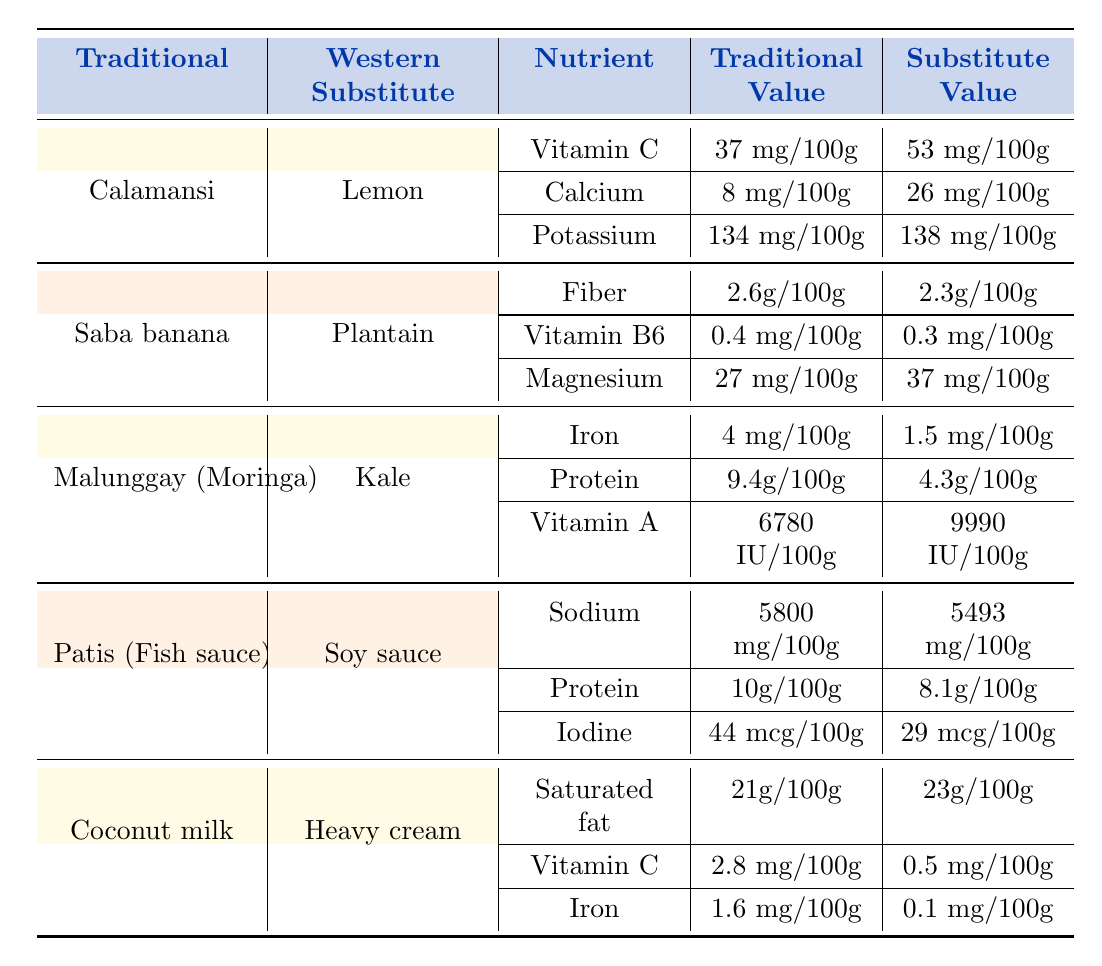What is the Vitamin C content of Calamansi and Lemon? The table shows that Calamansi contains 37 mg of Vitamin C per 100g, while Lemon has 53 mg per 100g.
Answer: Calamansi: 37 mg, Lemon: 53 mg Is the Iron content higher in Malunggay or Kale? According to the table, Malunggay contains 4 mg of Iron per 100g, while Kale has only 1.5 mg per 100g. Therefore, Malunggay has a higher Iron content.
Answer: Yes, Malunggay has higher Iron content What is the difference in Protein content between Patis and Soy sauce? The table indicates that Patis has 10 g of Protein per 100g, and Soy sauce has 8.1 g per 100g. Therefore, the difference is 10 g - 8.1 g = 1.9 g.
Answer: 1.9 g Which ingredient has the highest amount of Vitamin A? Looking at the table, Malunggay has 6780 IU of Vitamin A per 100g, which is higher than both Kale (9990 IU), so despite that Kale has more Vitamin A, the question asks for the highest amount overall amongst the listed ingredients, that would be Kale being the ingredient with the highest Vitamin A at 9990 IU per 100g.
Answer: Kale has the highest Vitamin A How does the Calcium content of Calamansi compare to that of Lemon? The table provides the Calcium content for Calamansi as 8 mg per 100g and for Lemon as 26 mg per 100g. This comparison shows that Lemon has significantly more Calcium than Calamansi.
Answer: Lemon has more Calcium 